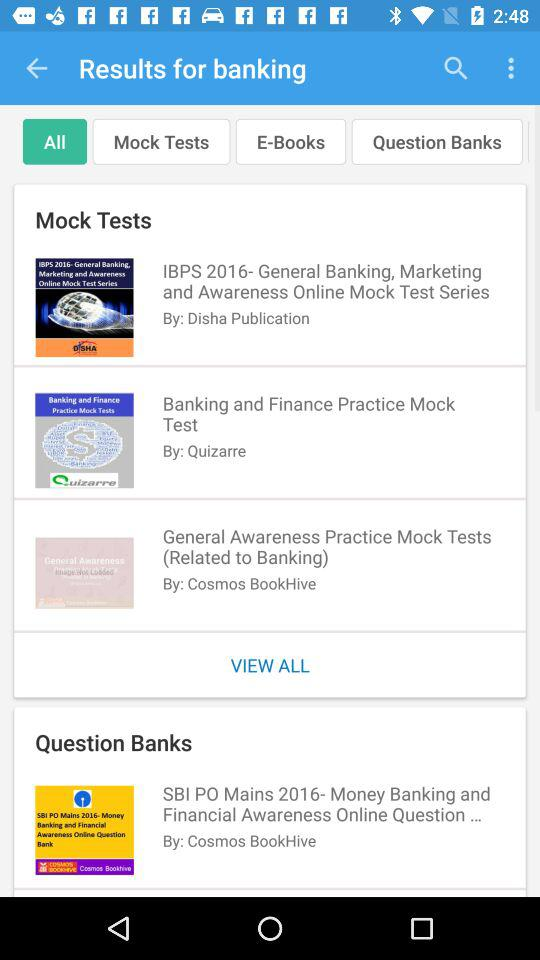Which tab is selected? The selected tab is "All". 